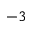Convert formula to latex. <formula><loc_0><loc_0><loc_500><loc_500>^ { - 3 }</formula> 